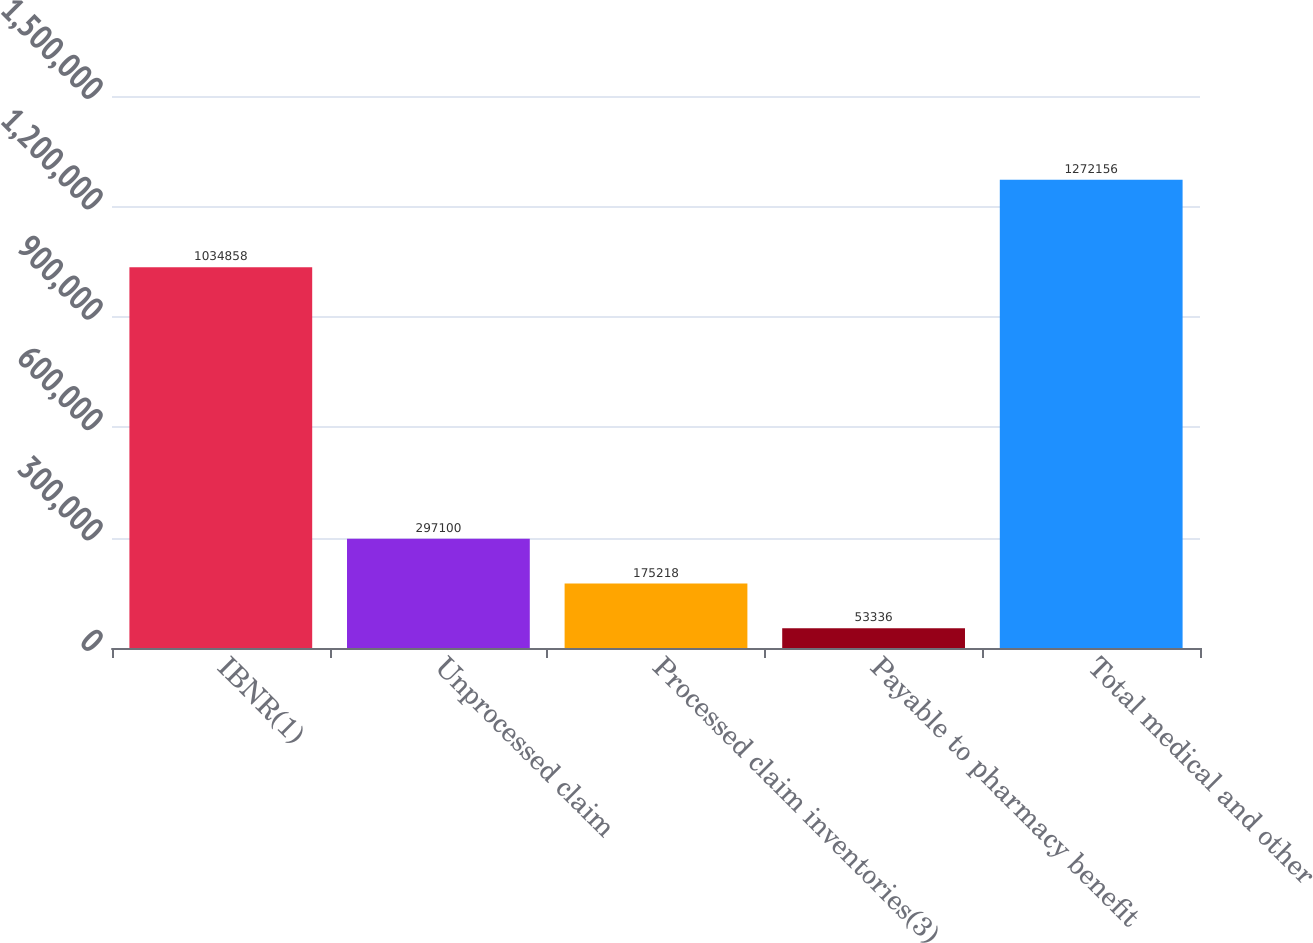Convert chart to OTSL. <chart><loc_0><loc_0><loc_500><loc_500><bar_chart><fcel>IBNR(1)<fcel>Unprocessed claim<fcel>Processed claim inventories(3)<fcel>Payable to pharmacy benefit<fcel>Total medical and other<nl><fcel>1.03486e+06<fcel>297100<fcel>175218<fcel>53336<fcel>1.27216e+06<nl></chart> 